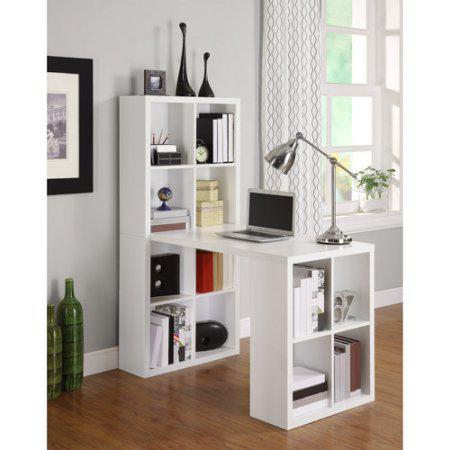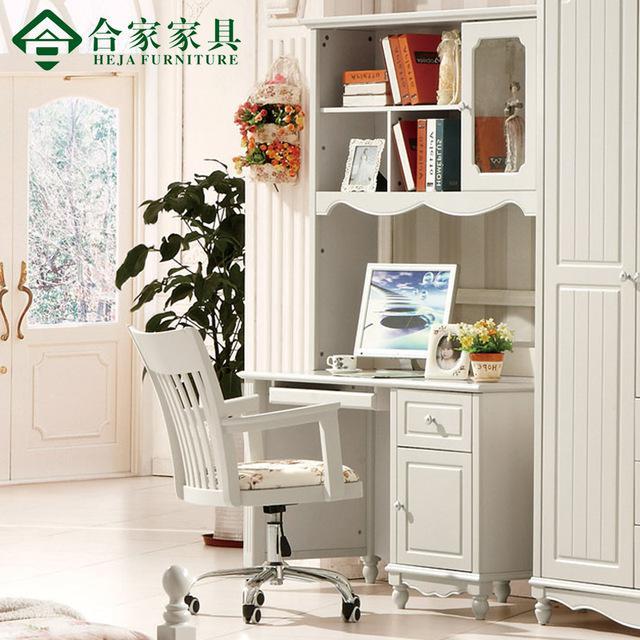The first image is the image on the left, the second image is the image on the right. Examine the images to the left and right. Is the description "One wall unit is cherry brown." accurate? Answer yes or no. No. The first image is the image on the left, the second image is the image on the right. Considering the images on both sides, is "The bookshelf on the right is burgundy in color and has a white laptop at its center, and the bookshelf on the left juts from the wall at an angle." valid? Answer yes or no. No. 